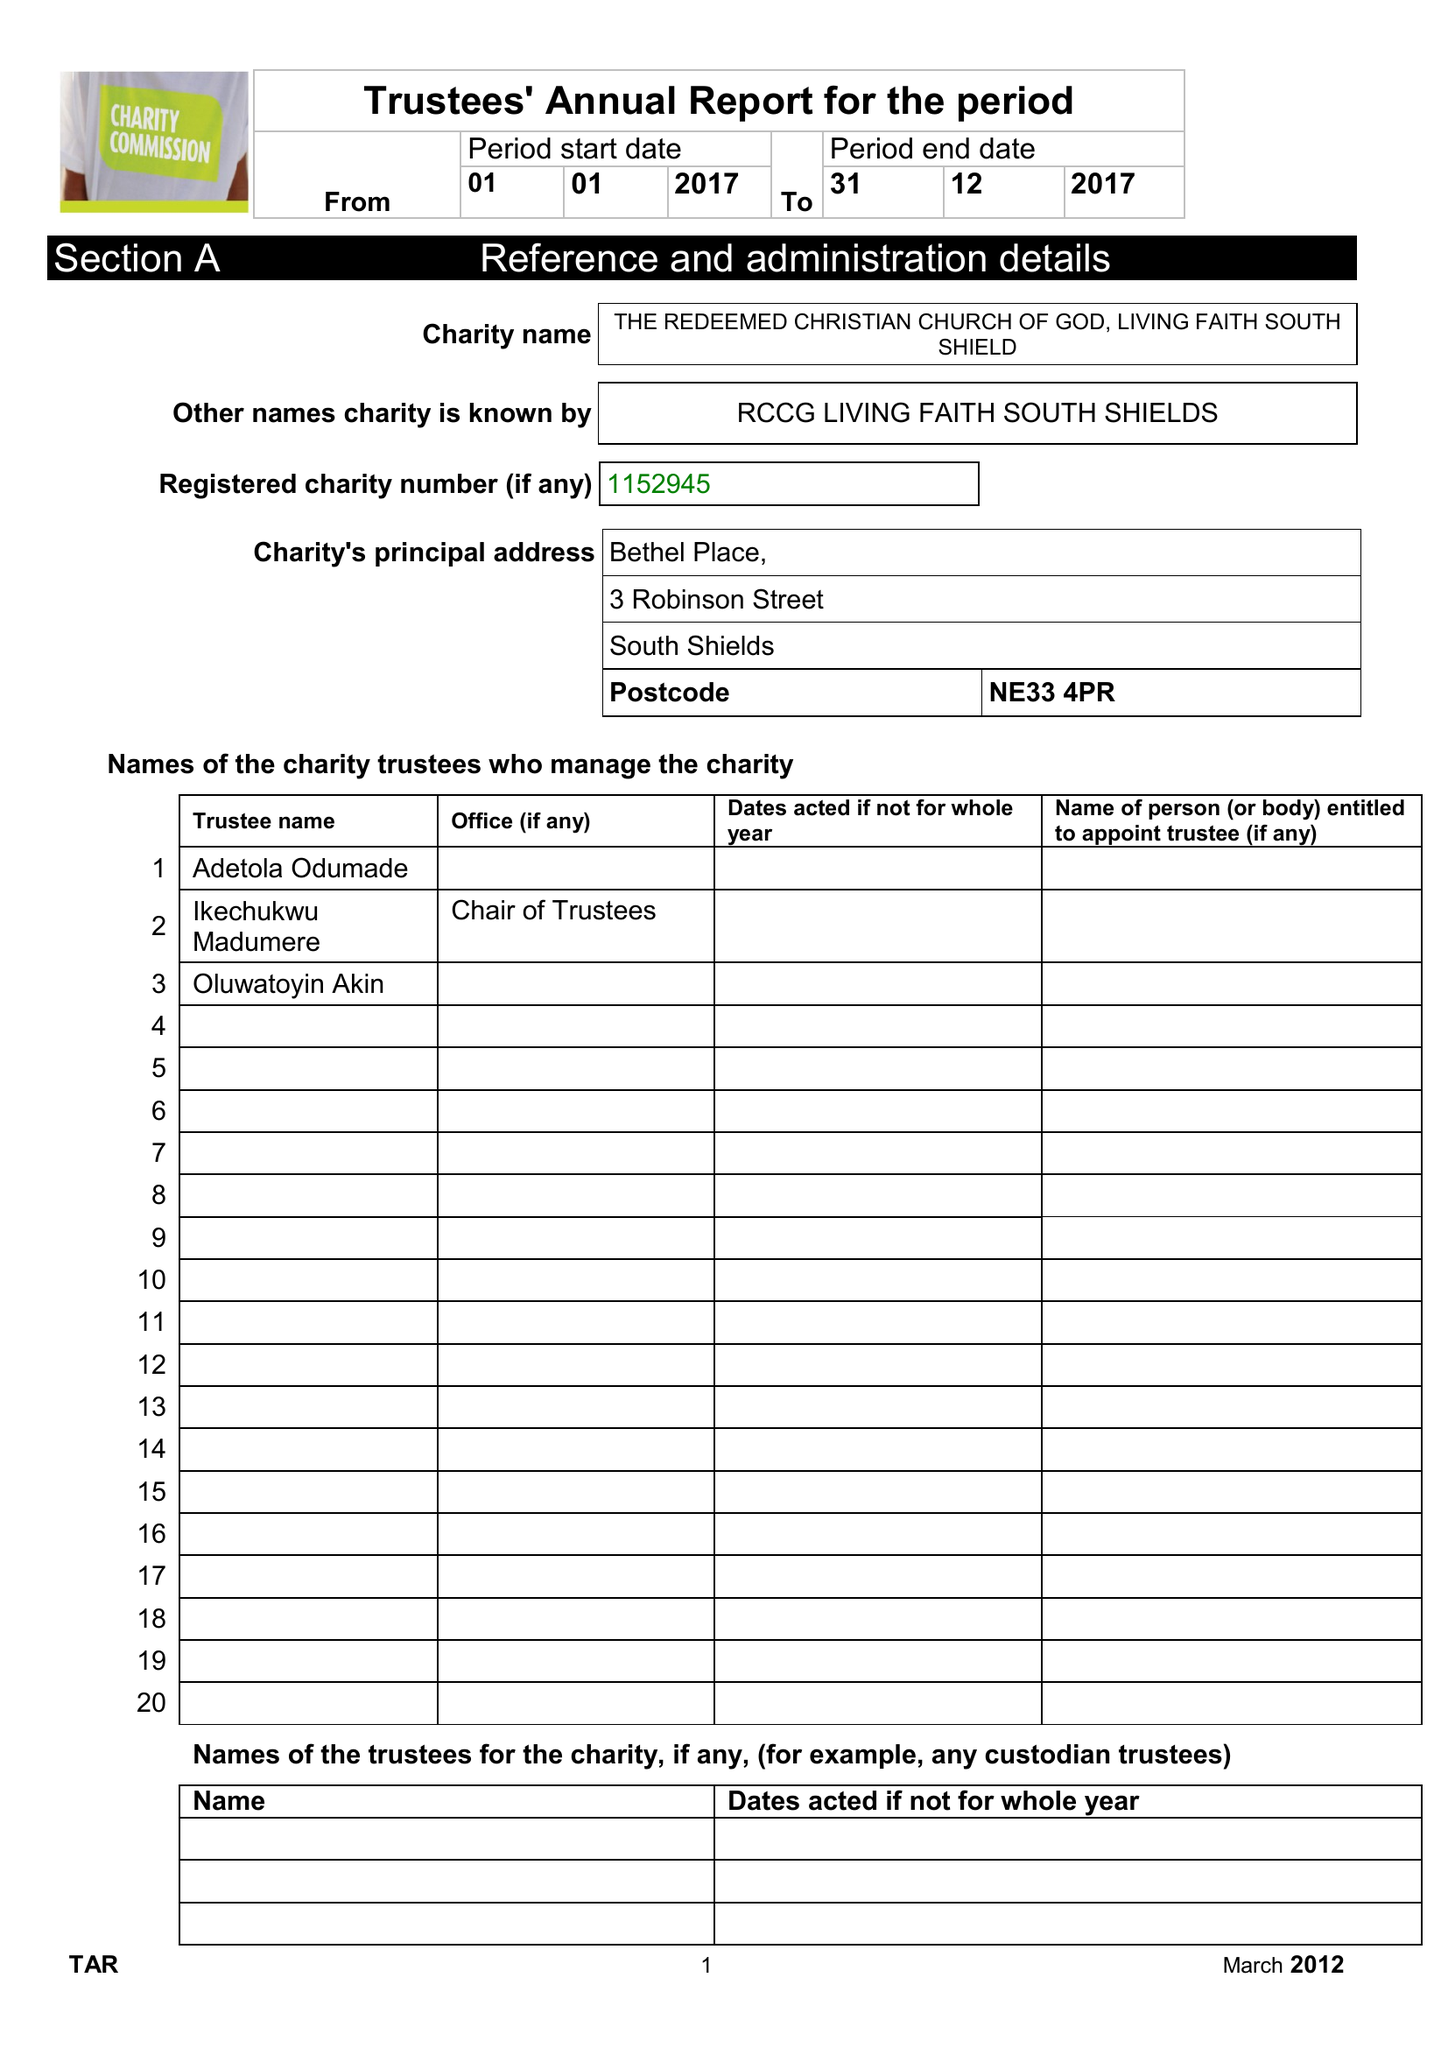What is the value for the income_annually_in_british_pounds?
Answer the question using a single word or phrase. 26073.00 